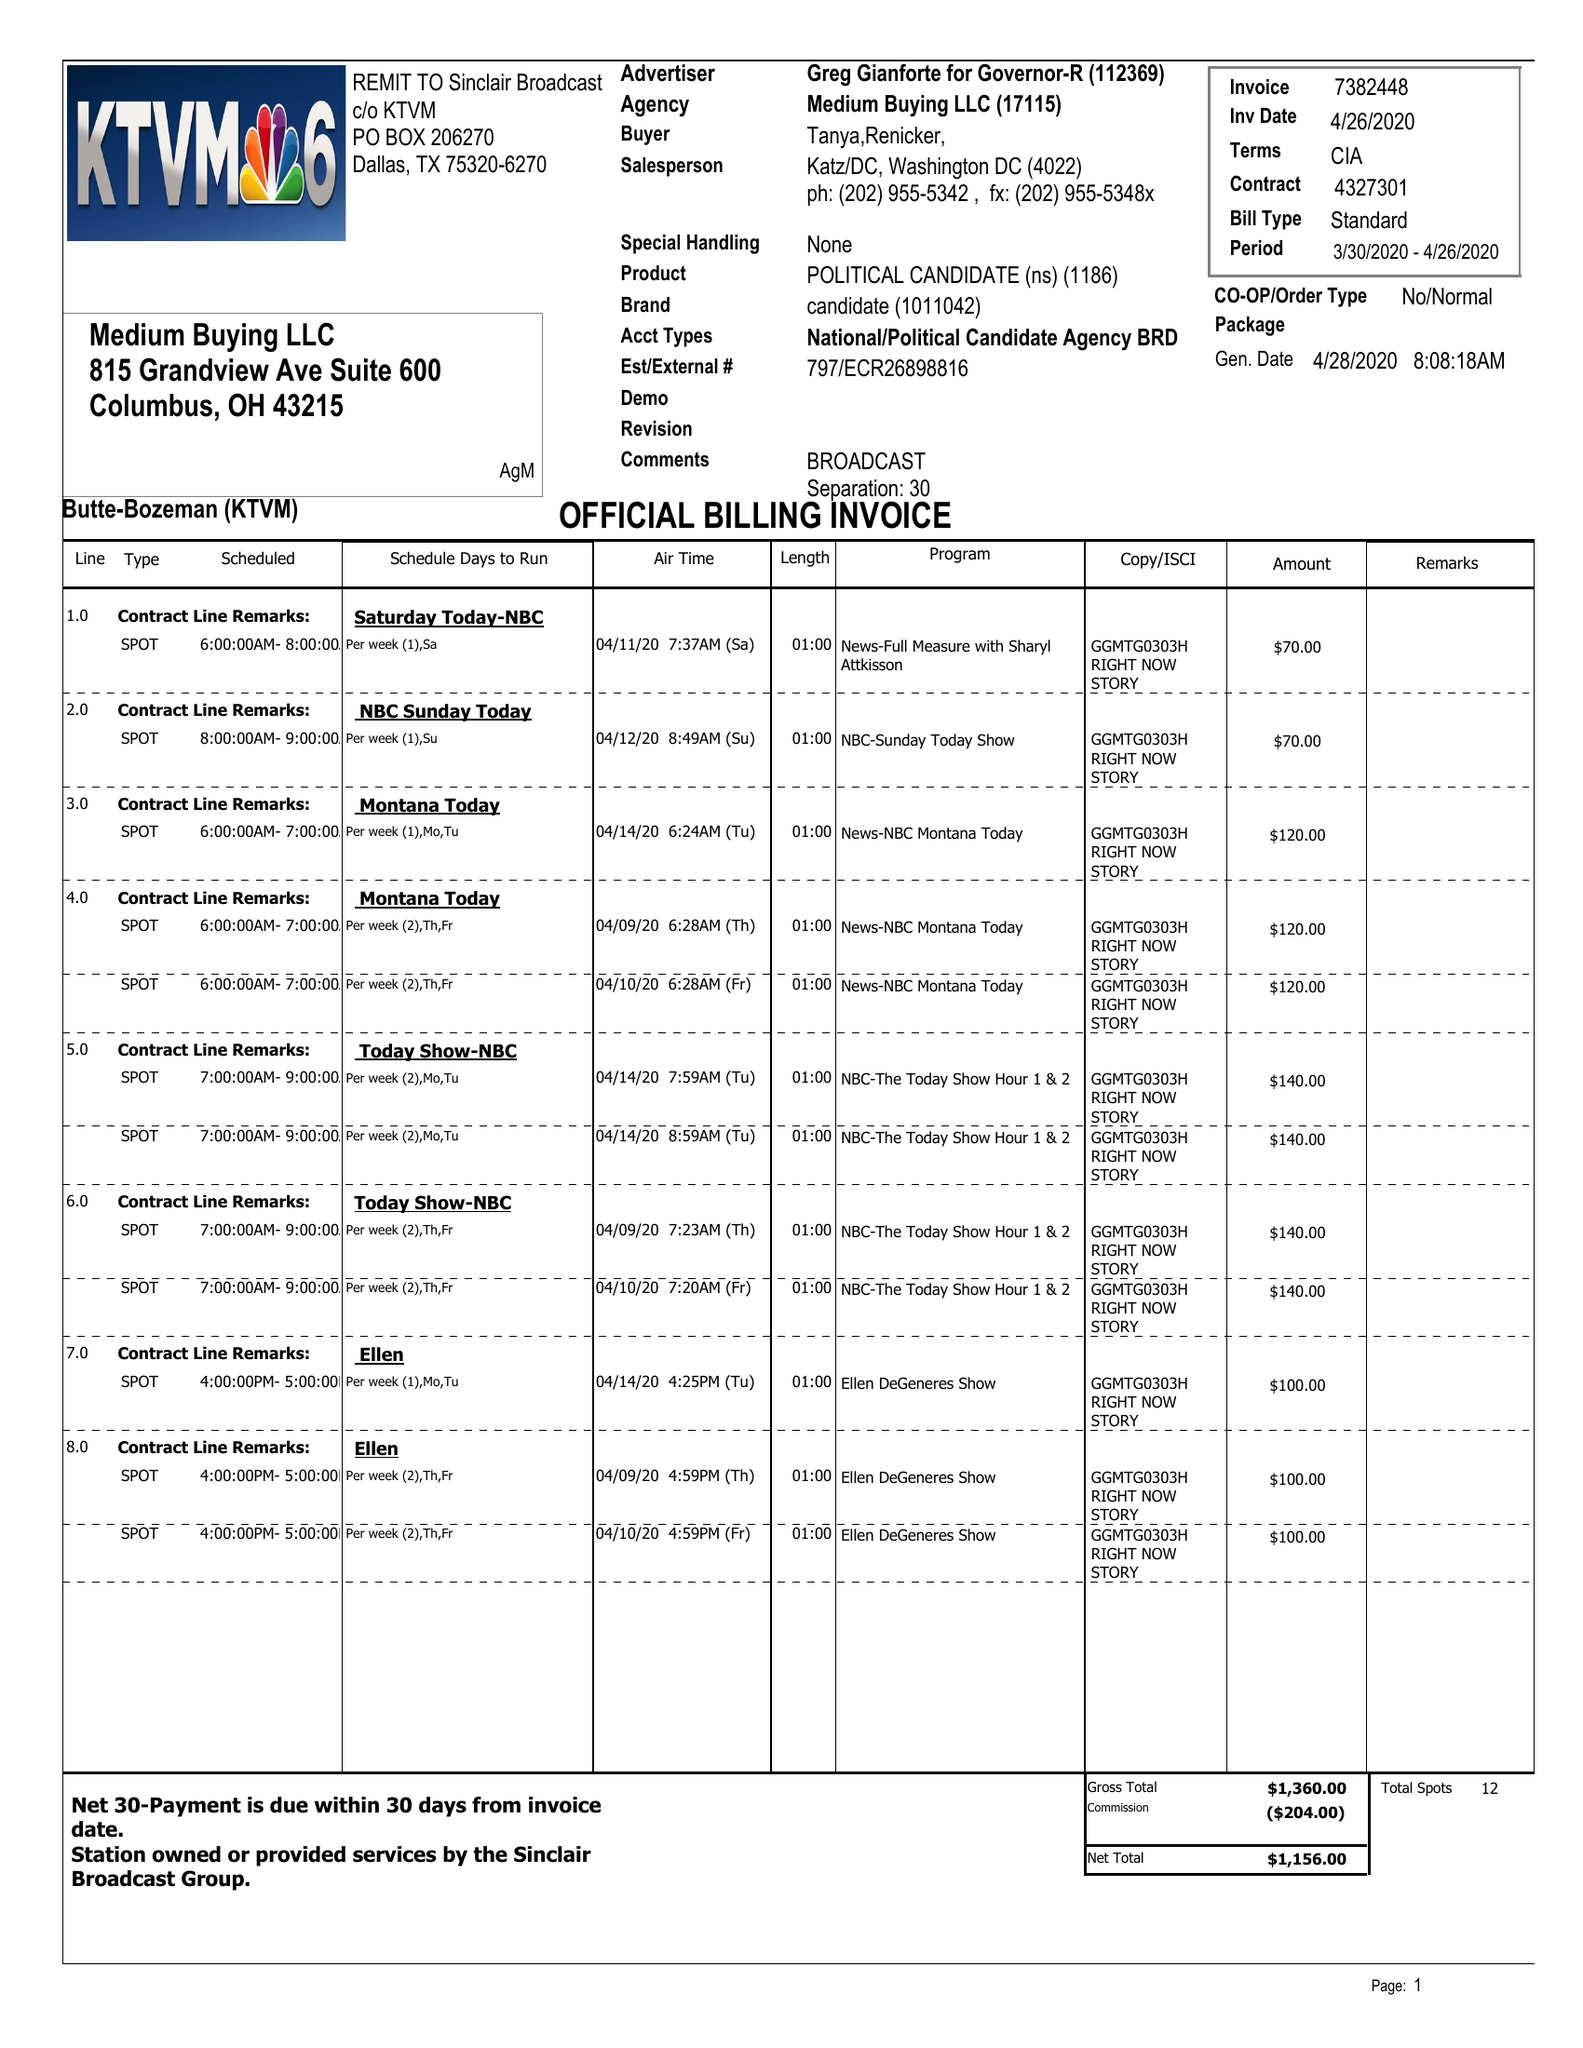What is the value for the gross_amount?
Answer the question using a single word or phrase. 1360.00 